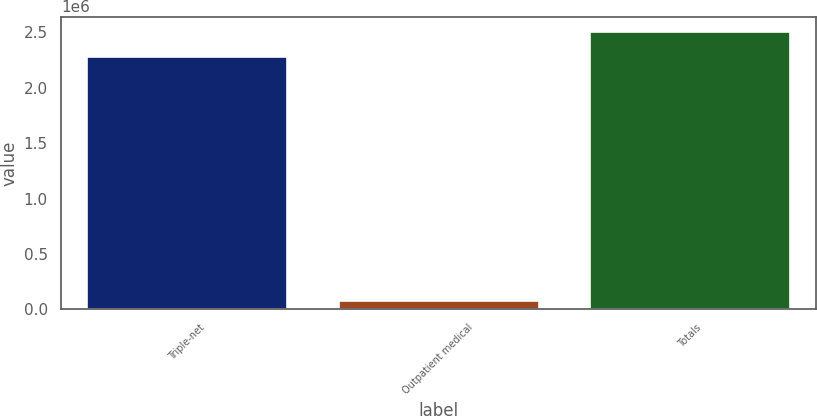Convert chart to OTSL. <chart><loc_0><loc_0><loc_500><loc_500><bar_chart><fcel>Triple-net<fcel>Outpatient medical<fcel>Totals<nl><fcel>2.28821e+06<fcel>80300<fcel>2.51703e+06<nl></chart> 